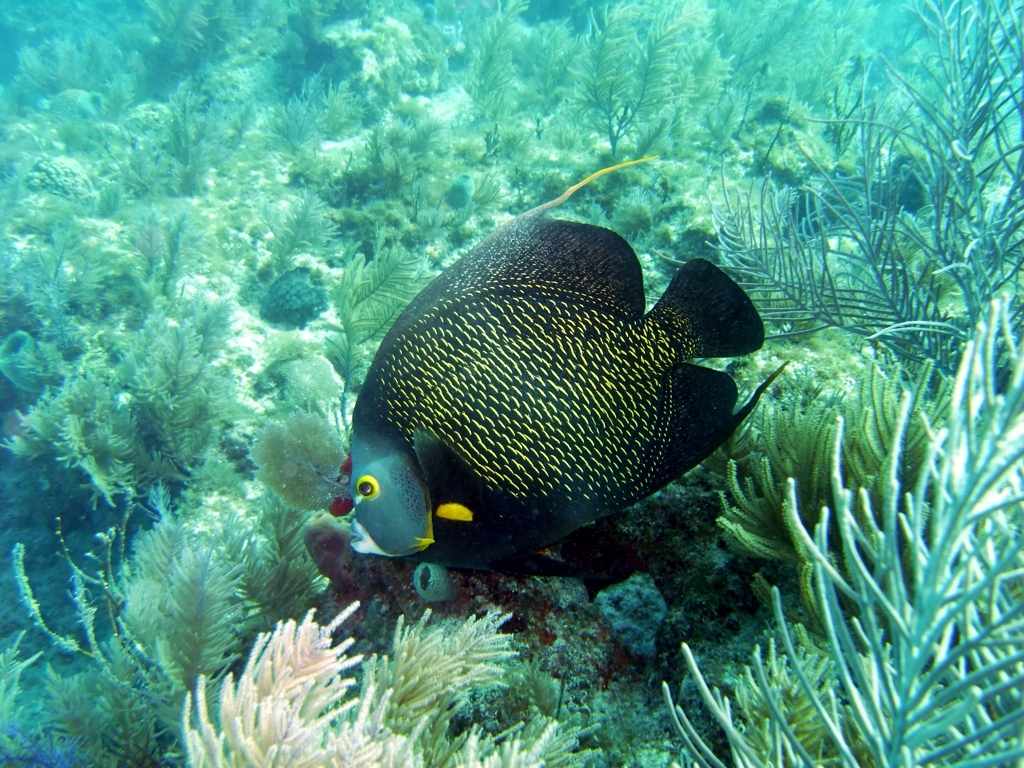What species of fish is depicted in this image? The fish in the image is a French Angelfish. It is recognizable by its black body with yellow-edged scales and bright yellow eye rings. What can you tell me about the habitat in which this fish lives? The French Angelfish is commonly found in coral reefs, which is its natural habitat. These complex ecosystems provide shelter and a variety of food sources essential for the survival of such species. The coral formations and seaweed offer protection against predators and places to forage for sponges and algae. 